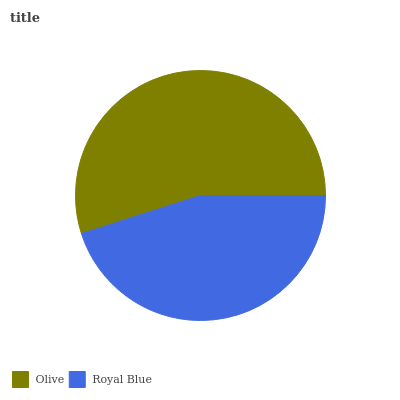Is Royal Blue the minimum?
Answer yes or no. Yes. Is Olive the maximum?
Answer yes or no. Yes. Is Royal Blue the maximum?
Answer yes or no. No. Is Olive greater than Royal Blue?
Answer yes or no. Yes. Is Royal Blue less than Olive?
Answer yes or no. Yes. Is Royal Blue greater than Olive?
Answer yes or no. No. Is Olive less than Royal Blue?
Answer yes or no. No. Is Olive the high median?
Answer yes or no. Yes. Is Royal Blue the low median?
Answer yes or no. Yes. Is Royal Blue the high median?
Answer yes or no. No. Is Olive the low median?
Answer yes or no. No. 